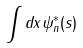<formula> <loc_0><loc_0><loc_500><loc_500>\int d x \psi _ { n } ^ { * } ( s )</formula> 